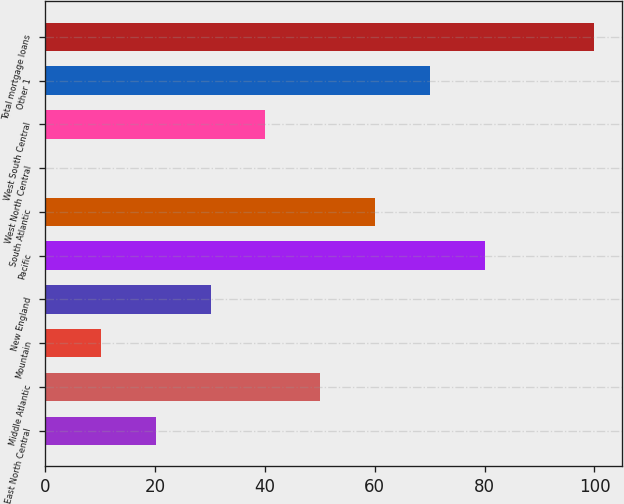Convert chart to OTSL. <chart><loc_0><loc_0><loc_500><loc_500><bar_chart><fcel>East North Central<fcel>Middle Atlantic<fcel>Mountain<fcel>New England<fcel>Pacific<fcel>South Atlantic<fcel>West North Central<fcel>West South Central<fcel>Other 1<fcel>Total mortgage loans<nl><fcel>20.16<fcel>50.1<fcel>10.18<fcel>30.14<fcel>80.04<fcel>60.08<fcel>0.2<fcel>40.12<fcel>70.06<fcel>100<nl></chart> 